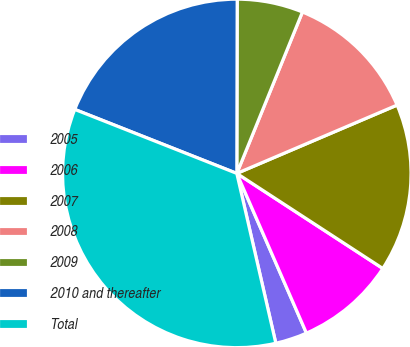Convert chart. <chart><loc_0><loc_0><loc_500><loc_500><pie_chart><fcel>2005<fcel>2006<fcel>2007<fcel>2008<fcel>2009<fcel>2010 and thereafter<fcel>Total<nl><fcel>2.95%<fcel>9.27%<fcel>15.6%<fcel>12.44%<fcel>6.11%<fcel>19.05%<fcel>34.58%<nl></chart> 